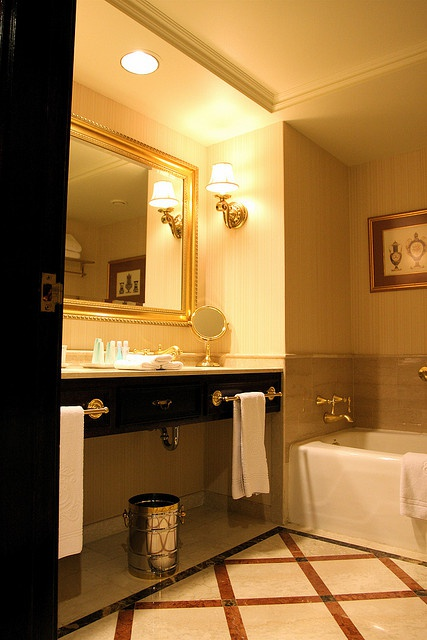Describe the objects in this image and their specific colors. I can see cup in lightyellow, khaki, lightgreen, and black tones and sink in khaki, beige, black, and lightyellow tones in this image. 